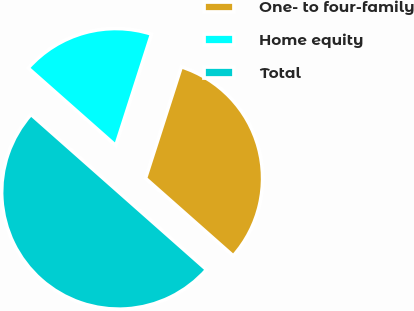Convert chart. <chart><loc_0><loc_0><loc_500><loc_500><pie_chart><fcel>One- to four-family<fcel>Home equity<fcel>Total<nl><fcel>31.58%<fcel>18.42%<fcel>50.0%<nl></chart> 